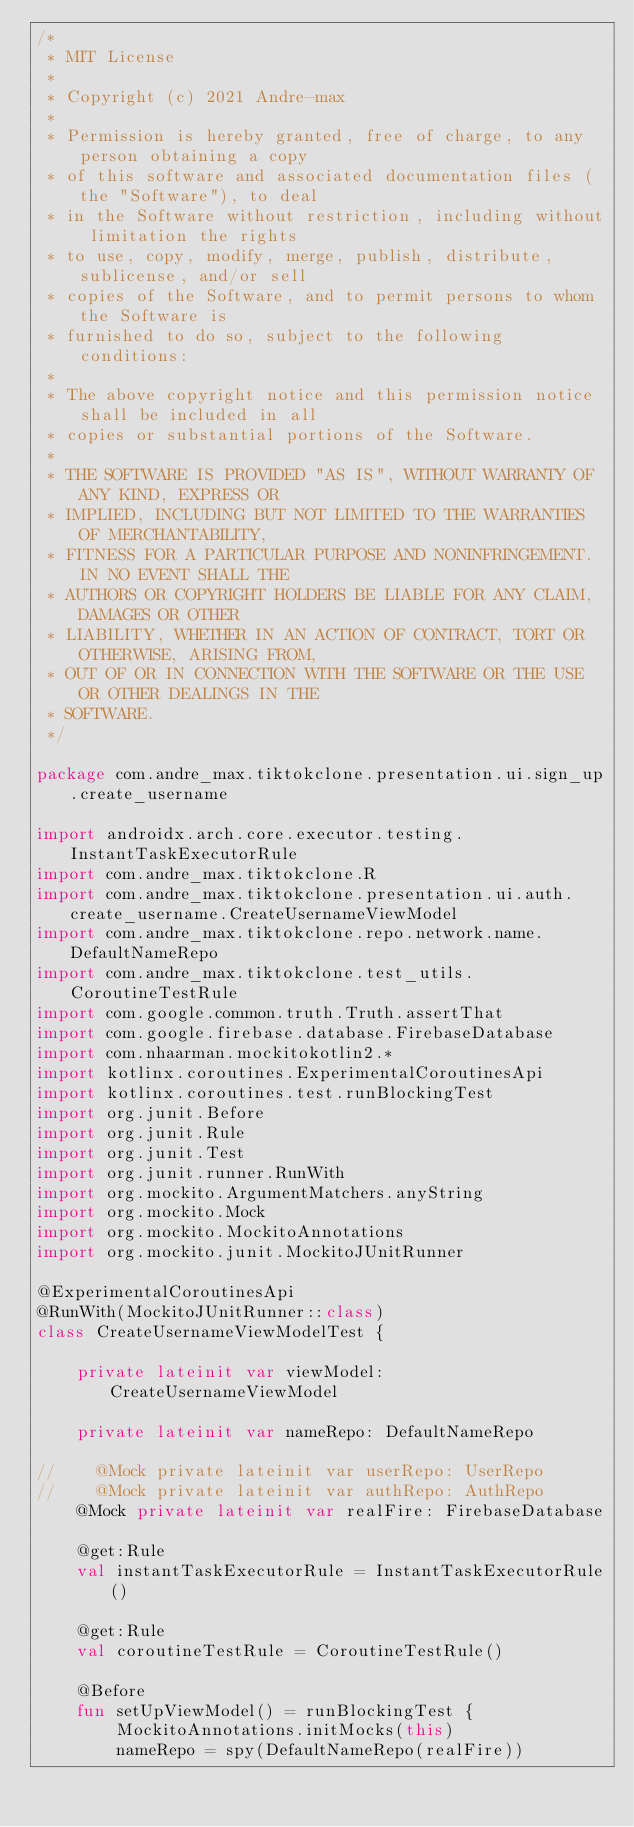Convert code to text. <code><loc_0><loc_0><loc_500><loc_500><_Kotlin_>/*
 * MIT License
 *
 * Copyright (c) 2021 Andre-max
 *
 * Permission is hereby granted, free of charge, to any person obtaining a copy
 * of this software and associated documentation files (the "Software"), to deal
 * in the Software without restriction, including without limitation the rights
 * to use, copy, modify, merge, publish, distribute, sublicense, and/or sell
 * copies of the Software, and to permit persons to whom the Software is
 * furnished to do so, subject to the following conditions:
 *
 * The above copyright notice and this permission notice shall be included in all
 * copies or substantial portions of the Software.
 *
 * THE SOFTWARE IS PROVIDED "AS IS", WITHOUT WARRANTY OF ANY KIND, EXPRESS OR
 * IMPLIED, INCLUDING BUT NOT LIMITED TO THE WARRANTIES OF MERCHANTABILITY,
 * FITNESS FOR A PARTICULAR PURPOSE AND NONINFRINGEMENT. IN NO EVENT SHALL THE
 * AUTHORS OR COPYRIGHT HOLDERS BE LIABLE FOR ANY CLAIM, DAMAGES OR OTHER
 * LIABILITY, WHETHER IN AN ACTION OF CONTRACT, TORT OR OTHERWISE, ARISING FROM,
 * OUT OF OR IN CONNECTION WITH THE SOFTWARE OR THE USE OR OTHER DEALINGS IN THE
 * SOFTWARE.
 */

package com.andre_max.tiktokclone.presentation.ui.sign_up.create_username

import androidx.arch.core.executor.testing.InstantTaskExecutorRule
import com.andre_max.tiktokclone.R
import com.andre_max.tiktokclone.presentation.ui.auth.create_username.CreateUsernameViewModel
import com.andre_max.tiktokclone.repo.network.name.DefaultNameRepo
import com.andre_max.tiktokclone.test_utils.CoroutineTestRule
import com.google.common.truth.Truth.assertThat
import com.google.firebase.database.FirebaseDatabase
import com.nhaarman.mockitokotlin2.*
import kotlinx.coroutines.ExperimentalCoroutinesApi
import kotlinx.coroutines.test.runBlockingTest
import org.junit.Before
import org.junit.Rule
import org.junit.Test
import org.junit.runner.RunWith
import org.mockito.ArgumentMatchers.anyString
import org.mockito.Mock
import org.mockito.MockitoAnnotations
import org.mockito.junit.MockitoJUnitRunner

@ExperimentalCoroutinesApi
@RunWith(MockitoJUnitRunner::class)
class CreateUsernameViewModelTest {

    private lateinit var viewModel: CreateUsernameViewModel

    private lateinit var nameRepo: DefaultNameRepo

//    @Mock private lateinit var userRepo: UserRepo
//    @Mock private lateinit var authRepo: AuthRepo
    @Mock private lateinit var realFire: FirebaseDatabase

    @get:Rule
    val instantTaskExecutorRule = InstantTaskExecutorRule()

    @get:Rule
    val coroutineTestRule = CoroutineTestRule()

    @Before
    fun setUpViewModel() = runBlockingTest {
        MockitoAnnotations.initMocks(this)
        nameRepo = spy(DefaultNameRepo(realFire))
</code> 